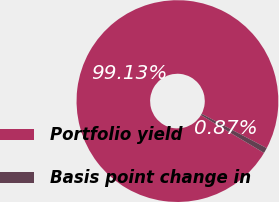Convert chart. <chart><loc_0><loc_0><loc_500><loc_500><pie_chart><fcel>Portfolio yield<fcel>Basis point change in<nl><fcel>99.13%<fcel>0.87%<nl></chart> 